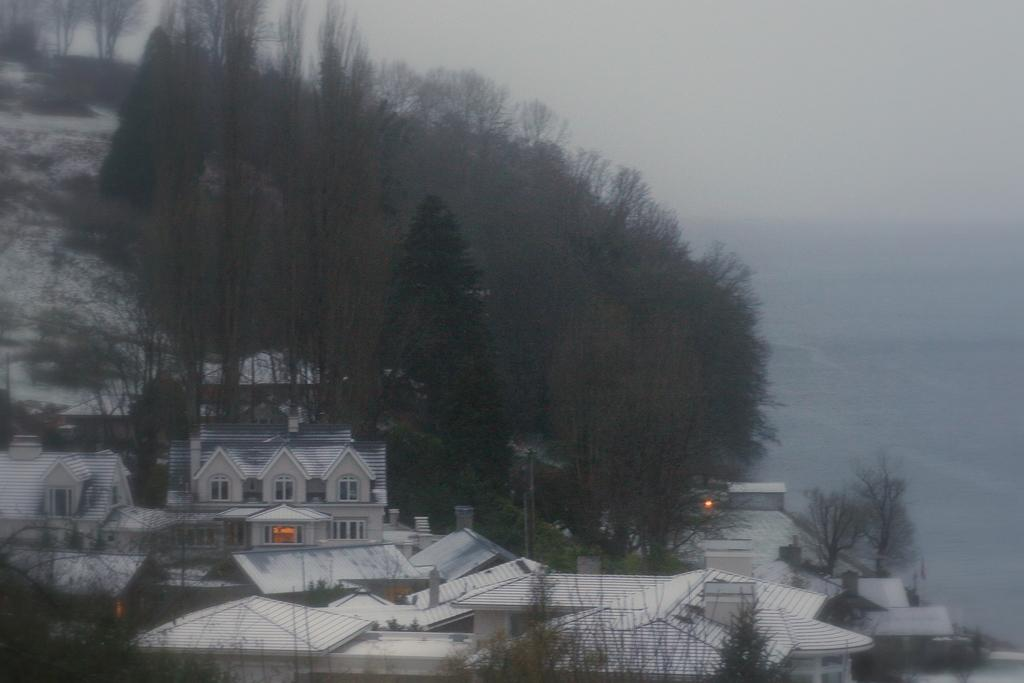What is located in the center of the image? There are buildings, lights, and trees in the center of the image. What can be seen in the background of the image? The sky is visible in the background of the image, and clouds are present. What type of cast can be seen on the buildings in the image? There is no cast present on the buildings in the image. How does the match between the trees and lights in the image work? There is no match between the trees and lights in the image; they are separate elements. 